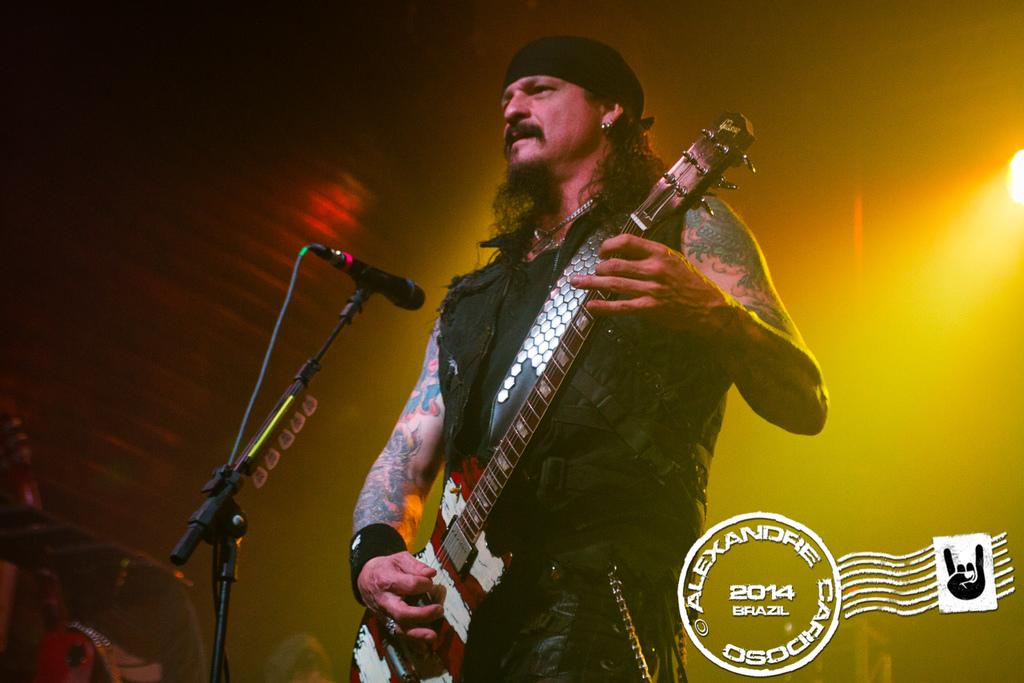What is the man in the image doing? The man is playing the guitar in the image. What is the man wearing on his head? The man is wearing a cap on his head. What can be seen on the left side of the image? There is a microphone on the left side of the image. What is visible on the right side of the image? There is light on the right side of the image. What color is the man's dress? The man is wearing a black color dress. What type of wax is being used to create the country in the image? There is no wax or country present in the image; it features a man playing the guitar. How many times does the man smile in the image? The image does not show the man smiling, so it cannot be determined how many times he smiles. 